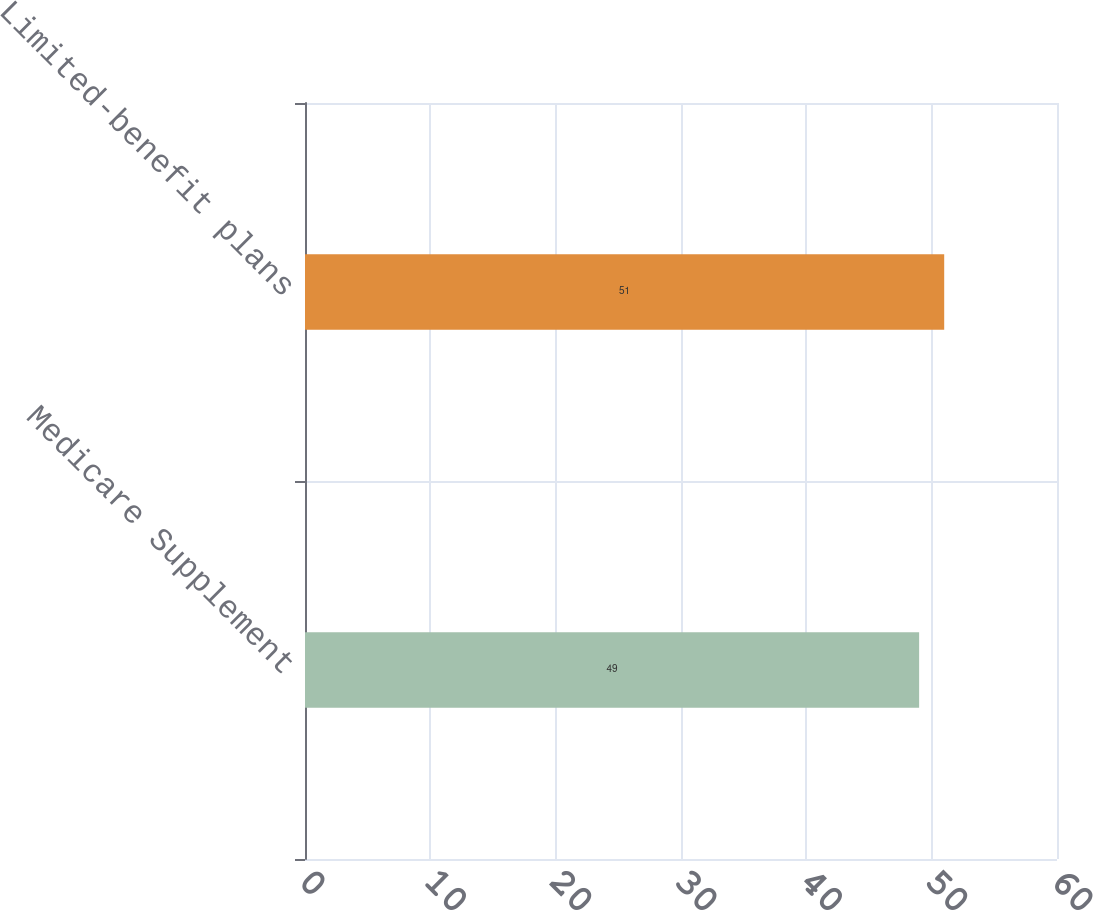Convert chart. <chart><loc_0><loc_0><loc_500><loc_500><bar_chart><fcel>Medicare Supplement<fcel>Limited-benefit plans<nl><fcel>49<fcel>51<nl></chart> 